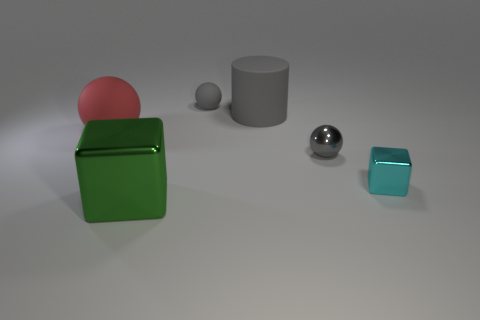Subtract all cyan cylinders. How many gray balls are left? 2 Subtract all small gray matte balls. How many balls are left? 2 Add 3 rubber spheres. How many objects exist? 9 Subtract all cylinders. How many objects are left? 5 Subtract 1 green cubes. How many objects are left? 5 Subtract all tiny gray balls. Subtract all small objects. How many objects are left? 1 Add 1 red objects. How many red objects are left? 2 Add 5 small balls. How many small balls exist? 7 